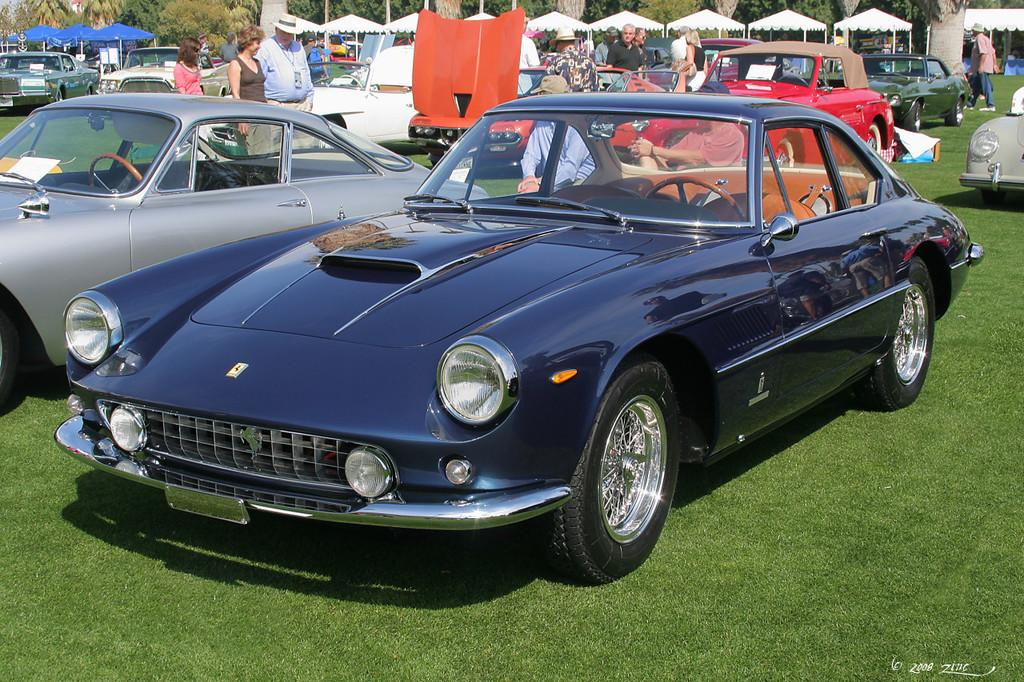What is the main subject in the center of the image? There are cars in the center of the image. What type of terrain is visible at the bottom side of the image? There is grassland at the bottom side of the image. What objects can be seen at the top side of the image? There are umbrellas at the top side of the image. What type of cake is being served on the grassland in the image? There is no cake present in the image; it features cars, grassland, and umbrellas. What is the condition of the sea in the image? There is no sea present in the image. 